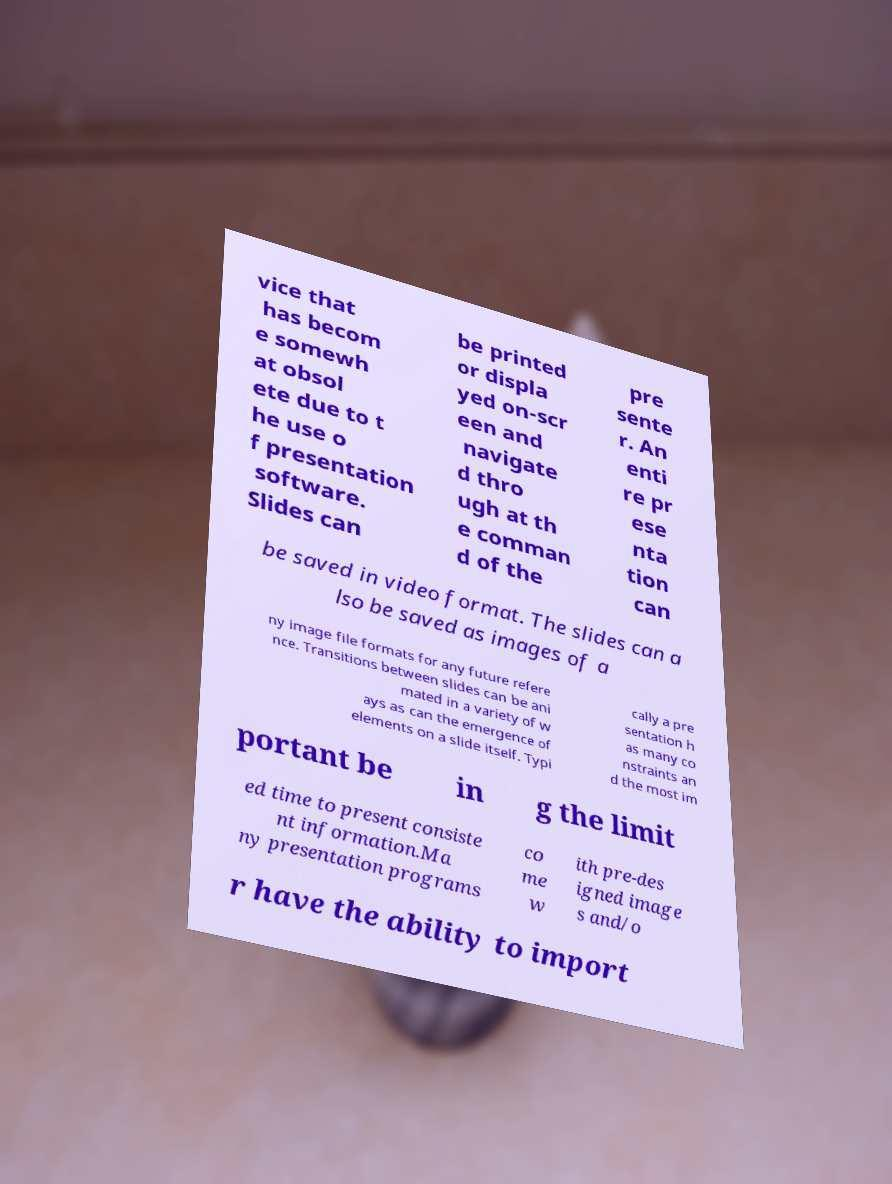Please read and relay the text visible in this image. What does it say? vice that has becom e somewh at obsol ete due to t he use o f presentation software. Slides can be printed or displa yed on-scr een and navigate d thro ugh at th e comman d of the pre sente r. An enti re pr ese nta tion can be saved in video format. The slides can a lso be saved as images of a ny image file formats for any future refere nce. Transitions between slides can be ani mated in a variety of w ays as can the emergence of elements on a slide itself. Typi cally a pre sentation h as many co nstraints an d the most im portant be in g the limit ed time to present consiste nt information.Ma ny presentation programs co me w ith pre-des igned image s and/o r have the ability to import 